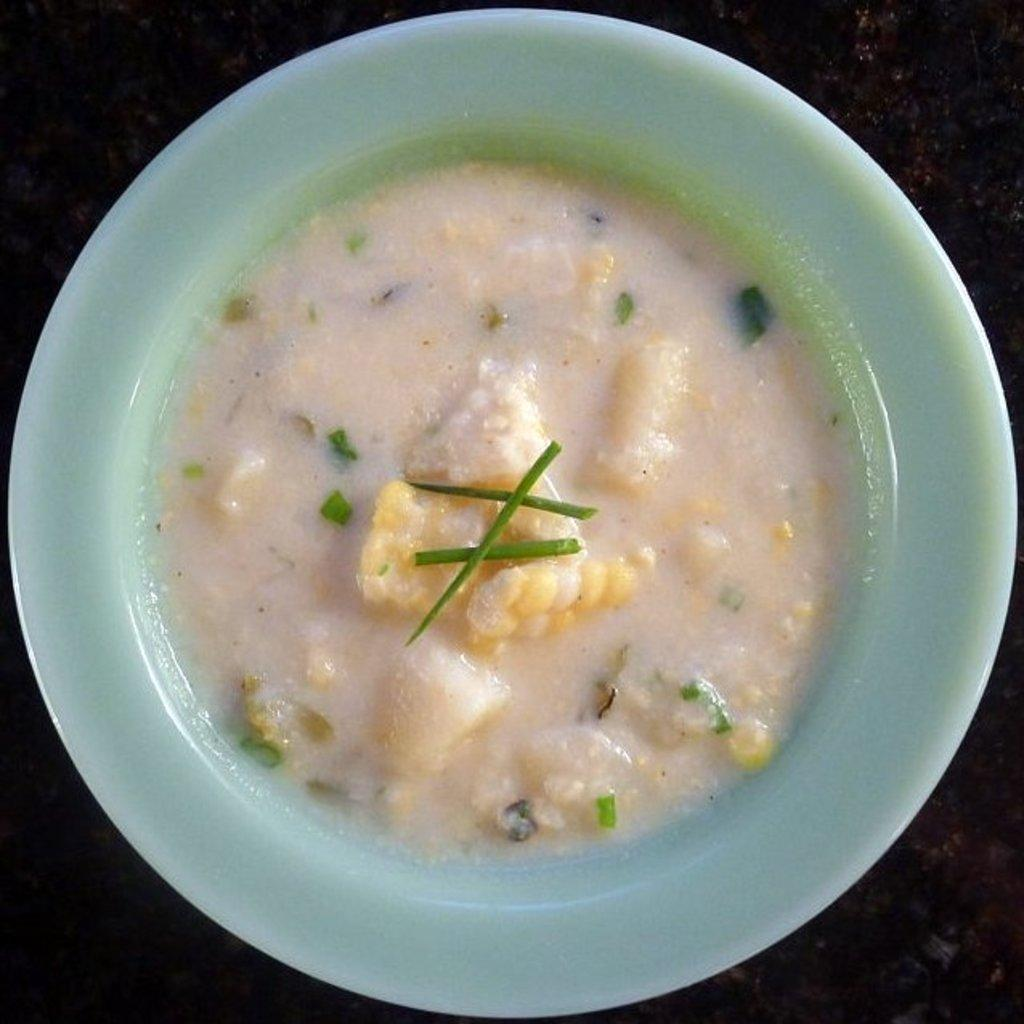What is on the plate in the image? There is food in the plate in the image. What type of surface is visible in the image? There is a dark surface visible in the image. How many pigs are helping to prepare the food in the image? There are no pigs present in the image, and they are not helping to prepare the food. What shape is the food in the image? The provided facts do not give information about the shape of the food in the image. 